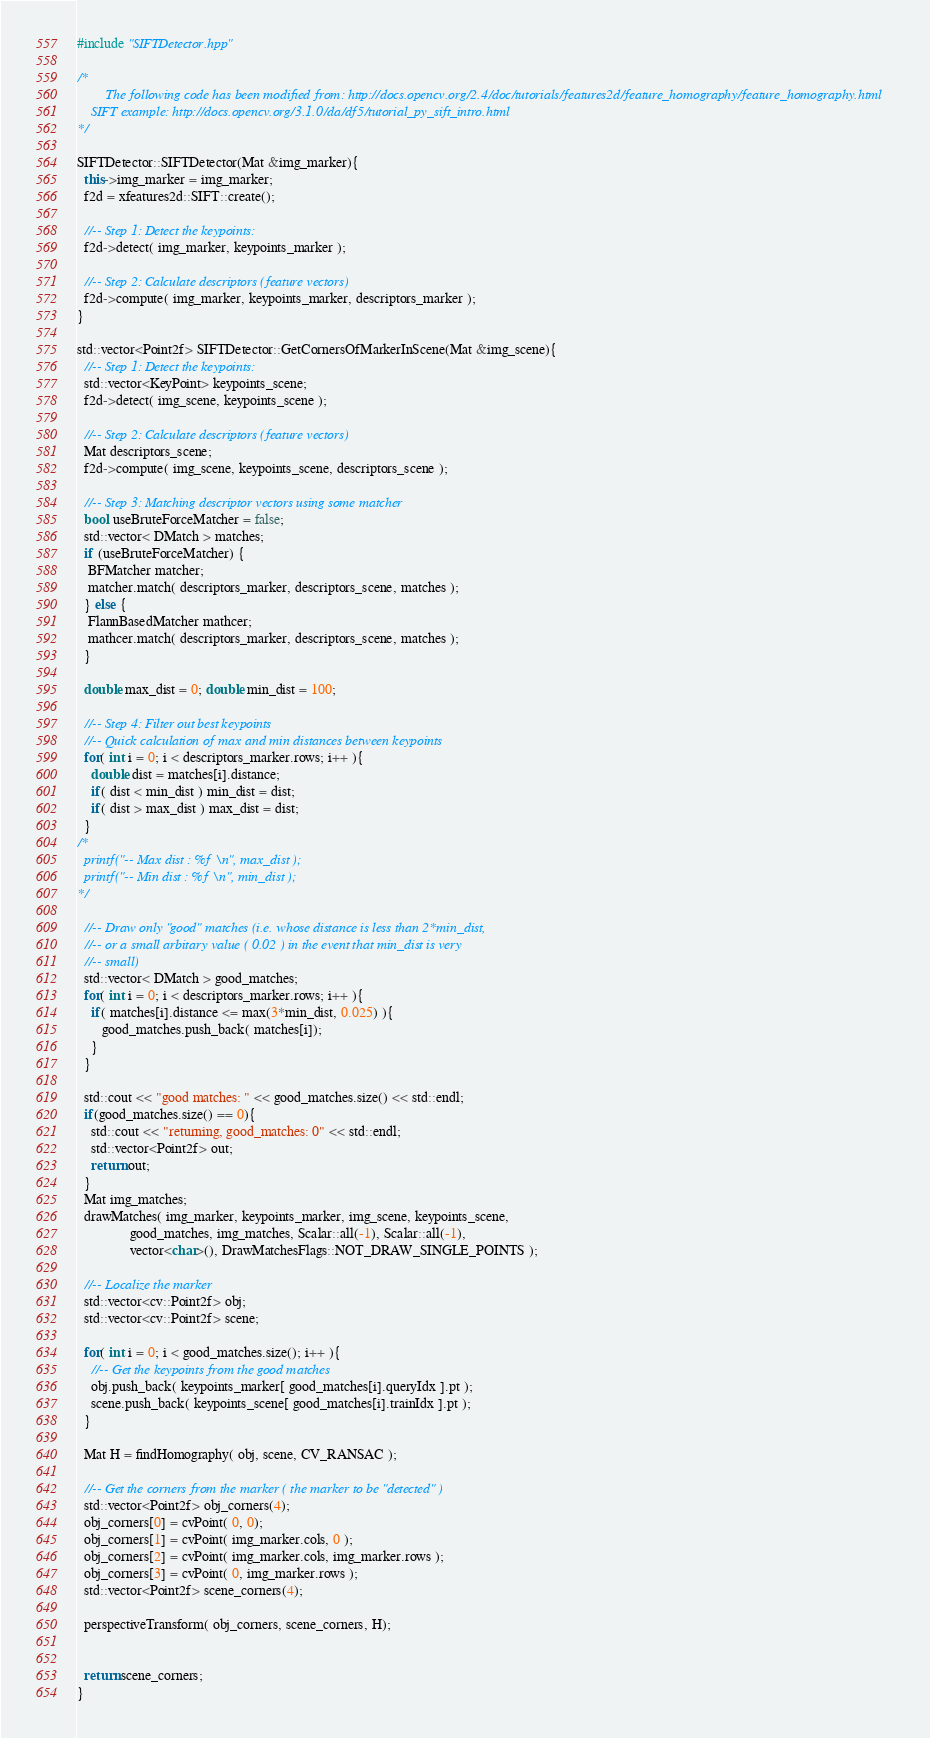<code> <loc_0><loc_0><loc_500><loc_500><_C++_>#include "SIFTDetector.hpp"

/*
        The following code has been modified from: http://docs.opencv.org/2.4/doc/tutorials/features2d/feature_homography/feature_homography.html
	SIFT example: http://docs.opencv.org/3.1.0/da/df5/tutorial_py_sift_intro.html
*/

SIFTDetector::SIFTDetector(Mat &img_marker){
  this->img_marker = img_marker;
  f2d = xfeatures2d::SIFT::create();

  //-- Step 1: Detect the keypoints:
  f2d->detect( img_marker, keypoints_marker );

  //-- Step 2: Calculate descriptors (feature vectors)
  f2d->compute( img_marker, keypoints_marker, descriptors_marker );
}

std::vector<Point2f> SIFTDetector::GetCornersOfMarkerInScene(Mat &img_scene){
  //-- Step 1: Detect the keypoints:
  std::vector<KeyPoint> keypoints_scene;
  f2d->detect( img_scene, keypoints_scene );

  //-- Step 2: Calculate descriptors (feature vectors)
  Mat descriptors_scene;
  f2d->compute( img_scene, keypoints_scene, descriptors_scene );

  //-- Step 3: Matching descriptor vectors using some matcher
  bool useBruteForceMatcher = false;
  std::vector< DMatch > matches;
  if (useBruteForceMatcher) {
   BFMatcher matcher;
   matcher.match( descriptors_marker, descriptors_scene, matches );
  } else {
   FlannBasedMatcher mathcer;
   mathcer.match( descriptors_marker, descriptors_scene, matches );
  }

  double max_dist = 0; double min_dist = 100;

  //-- Step 4: Filter out best keypoints
  //-- Quick calculation of max and min distances between keypoints
  for( int i = 0; i < descriptors_marker.rows; i++ ){
    double dist = matches[i].distance;
    if( dist < min_dist ) min_dist = dist;
    if( dist > max_dist ) max_dist = dist;
  }
/*
  printf("-- Max dist : %f \n", max_dist );
  printf("-- Min dist : %f \n", min_dist );
*/

  //-- Draw only "good" matches (i.e. whose distance is less than 2*min_dist,
  //-- or a small arbitary value ( 0.02 ) in the event that min_dist is very
  //-- small)
  std::vector< DMatch > good_matches;
  for( int i = 0; i < descriptors_marker.rows; i++ ){
    if( matches[i].distance <= max(3*min_dist, 0.025) ){
       good_matches.push_back( matches[i]);
    }
  }

  std::cout << "good matches: " << good_matches.size() << std::endl;
  if(good_matches.size() == 0){
    std::cout << "returning, good_matches: 0" << std::endl;
    std::vector<Point2f> out;
    return out;
  }
  Mat img_matches;
  drawMatches( img_marker, keypoints_marker, img_scene, keypoints_scene,
               good_matches, img_matches, Scalar::all(-1), Scalar::all(-1),
               vector<char>(), DrawMatchesFlags::NOT_DRAW_SINGLE_POINTS );

  //-- Localize the marker
  std::vector<cv::Point2f> obj;
  std::vector<cv::Point2f> scene;

  for( int i = 0; i < good_matches.size(); i++ ){
    //-- Get the keypoints from the good matches
    obj.push_back( keypoints_marker[ good_matches[i].queryIdx ].pt );
    scene.push_back( keypoints_scene[ good_matches[i].trainIdx ].pt );
  }

  Mat H = findHomography( obj, scene, CV_RANSAC );

  //-- Get the corners from the marker ( the marker to be "detected" )
  std::vector<Point2f> obj_corners(4);
  obj_corners[0] = cvPoint( 0, 0);
  obj_corners[1] = cvPoint( img_marker.cols, 0 );
  obj_corners[2] = cvPoint( img_marker.cols, img_marker.rows );
  obj_corners[3] = cvPoint( 0, img_marker.rows );
  std::vector<Point2f> scene_corners(4);

  perspectiveTransform( obj_corners, scene_corners, H);


  return scene_corners;
}
</code> 